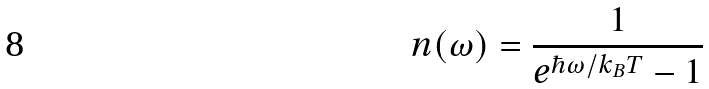<formula> <loc_0><loc_0><loc_500><loc_500>n ( \omega ) = \frac { 1 } { e ^ { \hbar { \omega } / k _ { B } T } - 1 }</formula> 